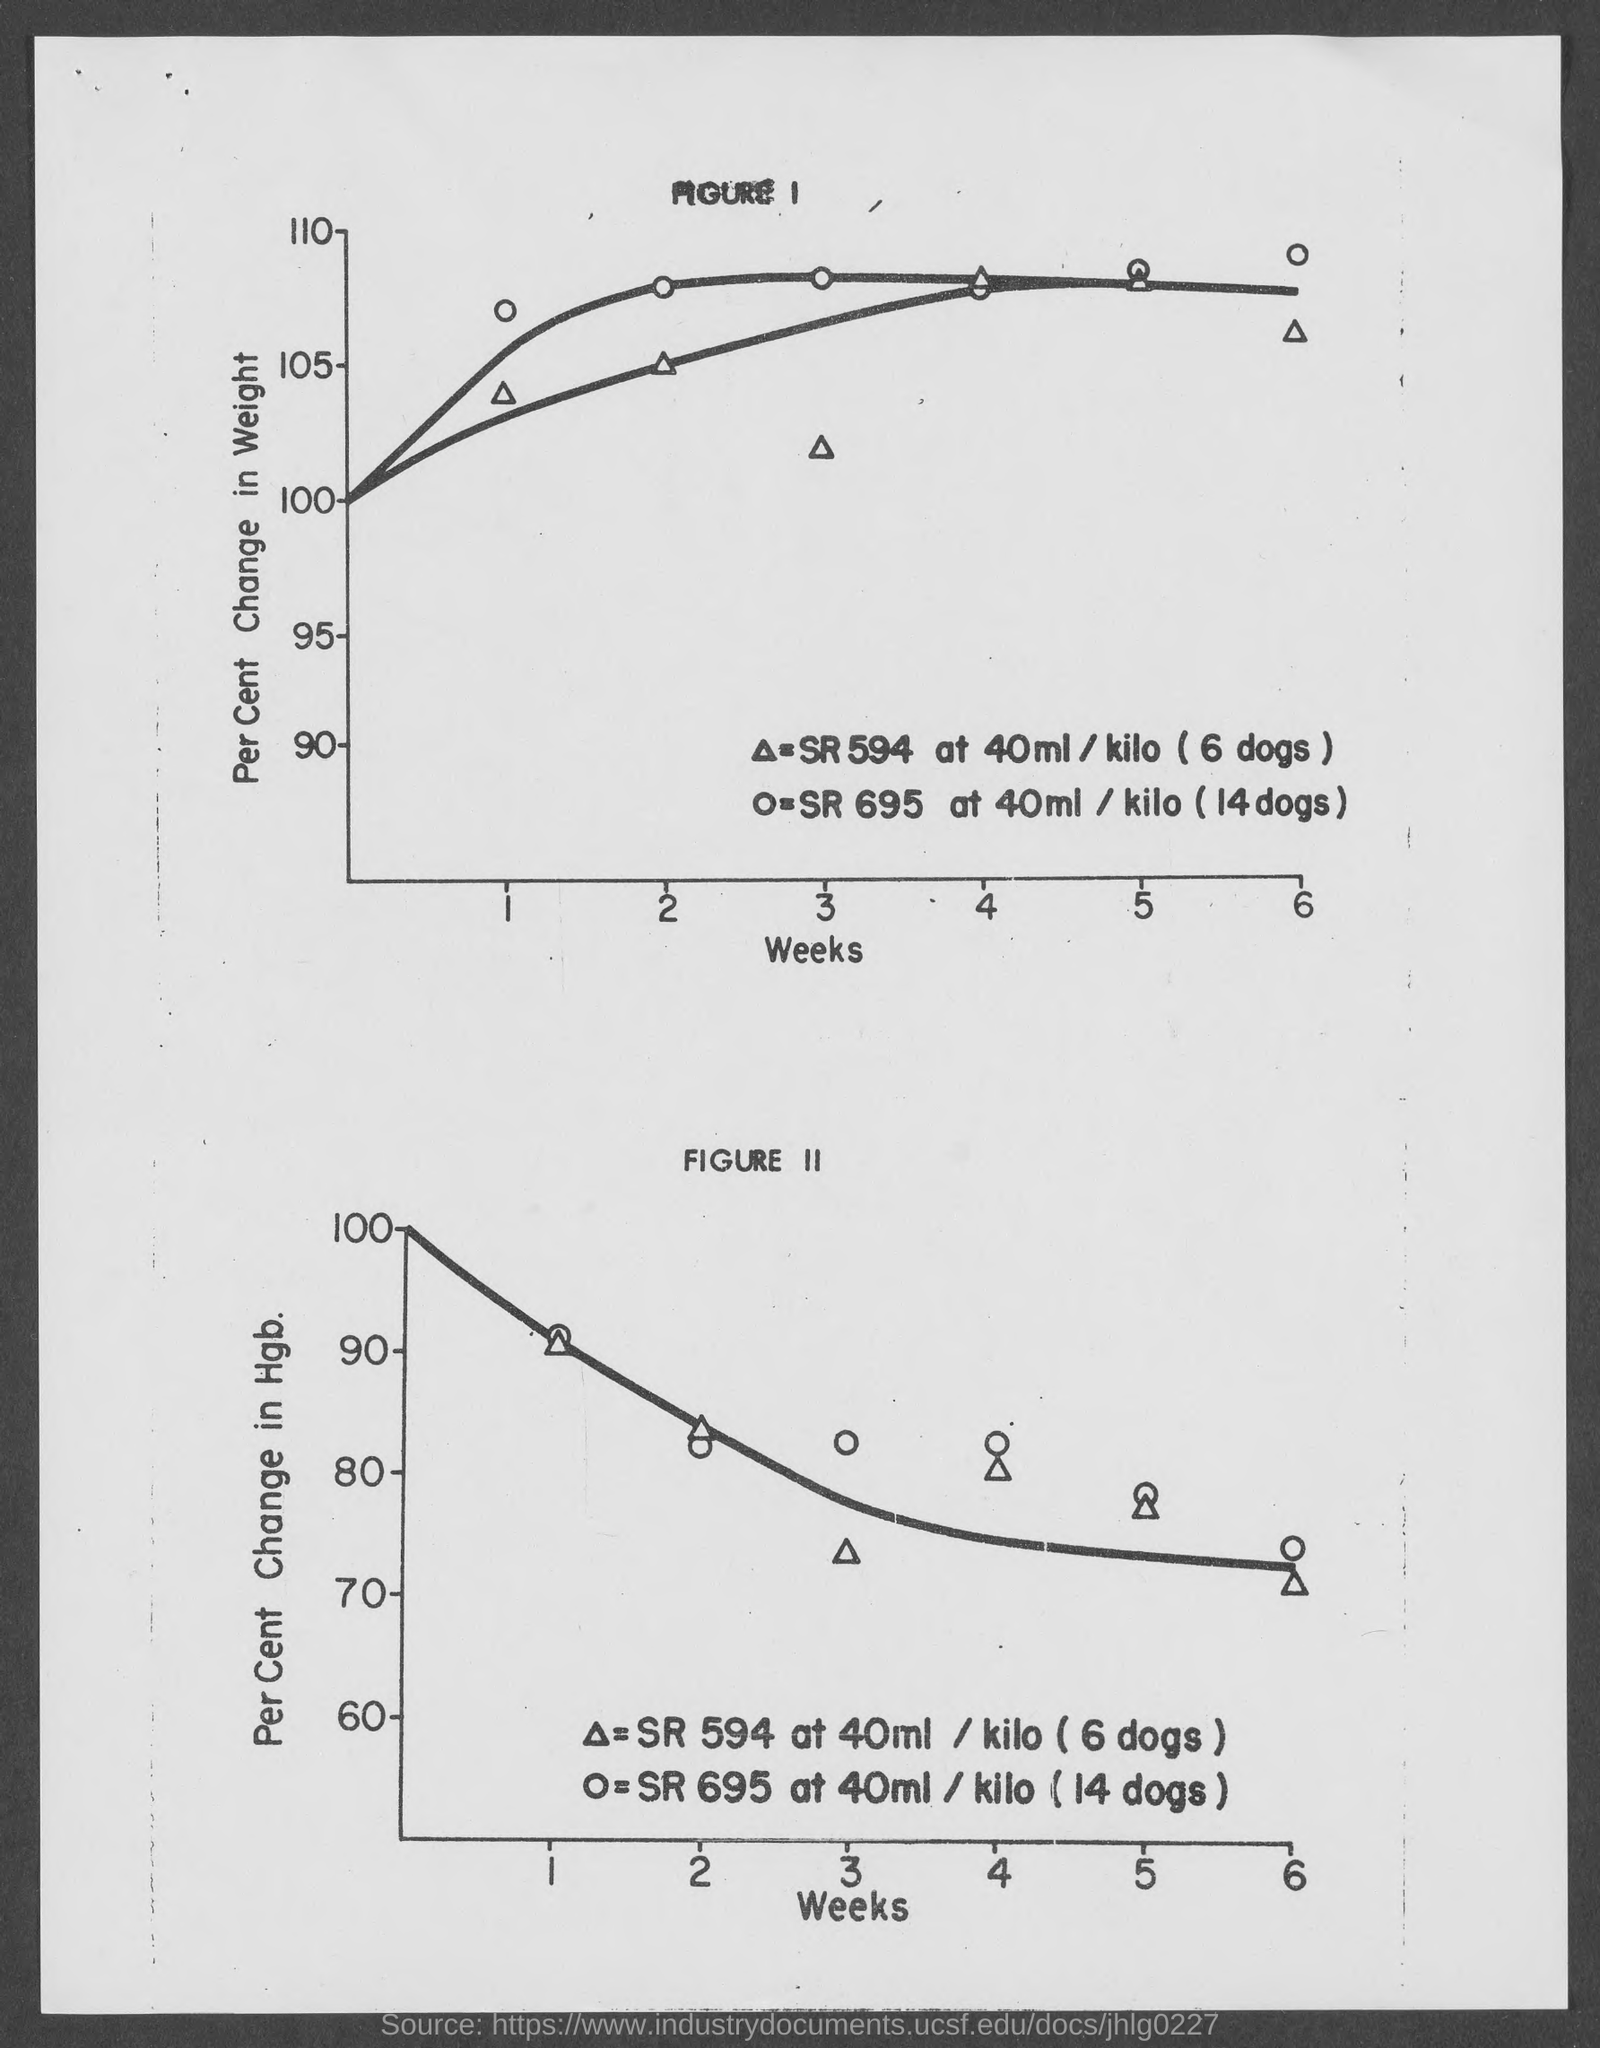Mention a couple of crucial points in this snapshot. The vertical axis of Figure 1 shows the percent change in weight of caterpillars that were exposed to a certain fungus, compared to the weight of caterpillars that were not exposed. The horizontal axis in Figure 2 represents the number of weeks. The horizontal axis of figure 1 represents weeks. 